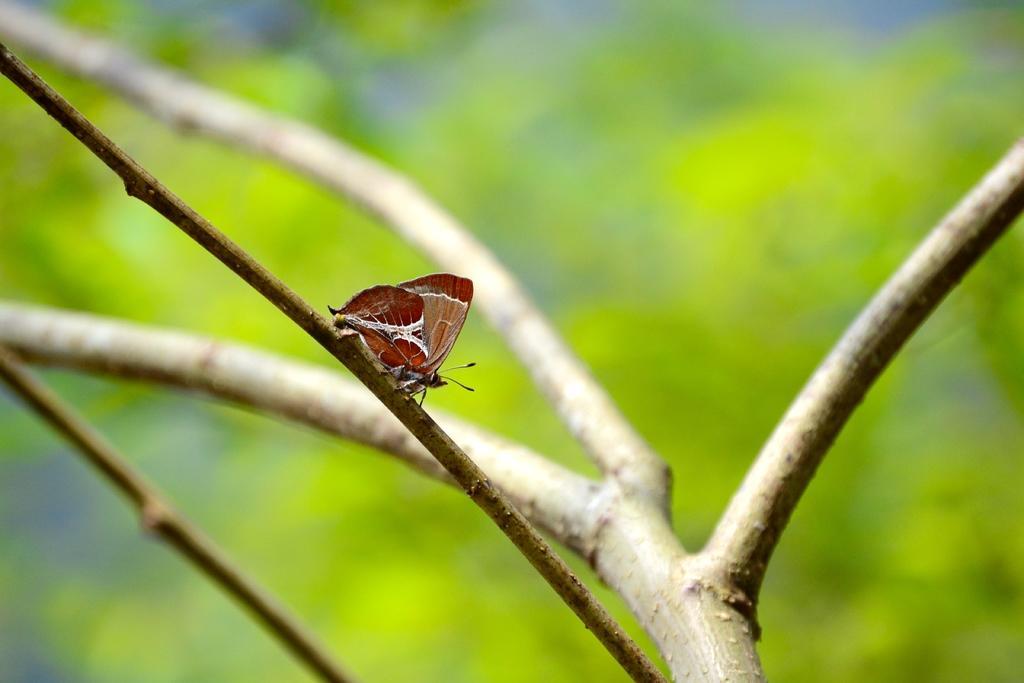How would you summarize this image in a sentence or two? In this image there is a butterfly on the branch of a tree and the background of the image is blur. 